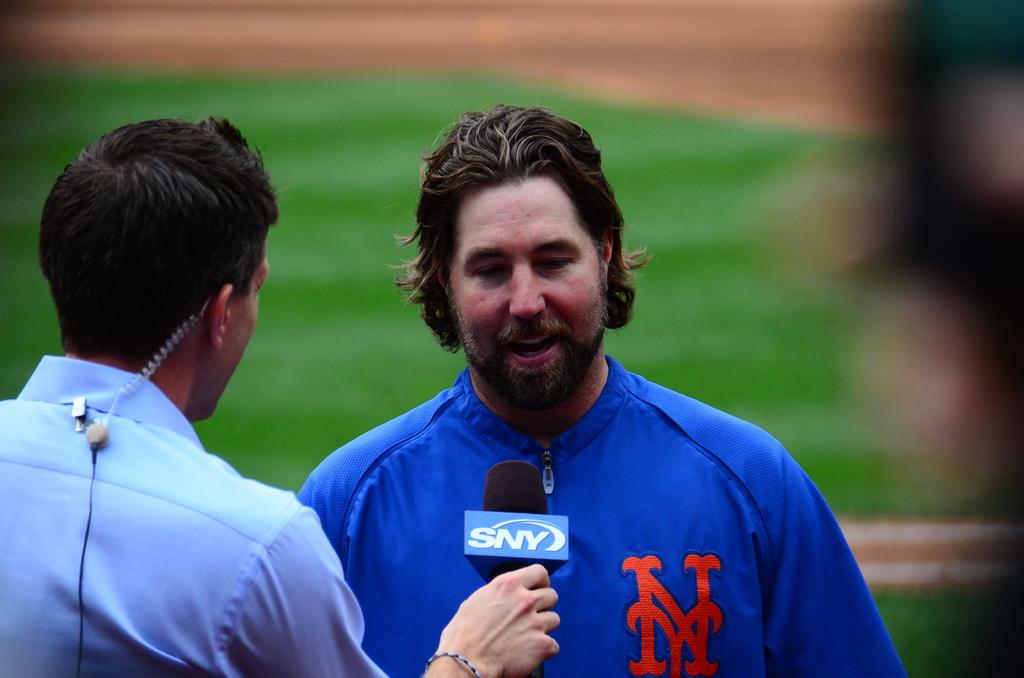What is the channel shown on the microphone?
Offer a terse response. Sny. What team is he playing for?
Make the answer very short. Ny. 